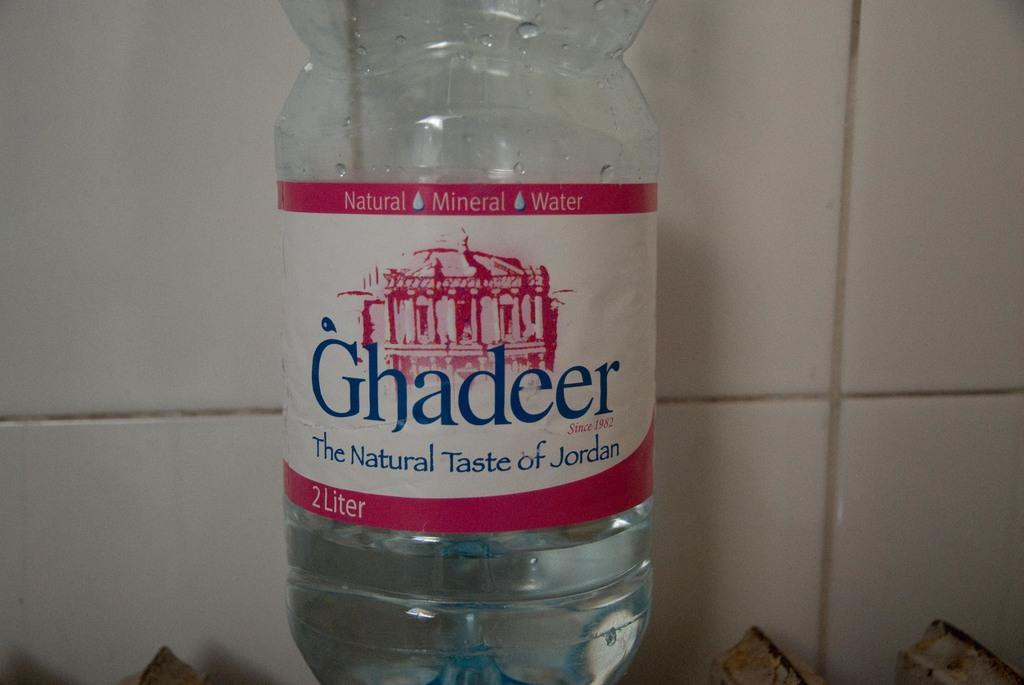<image>
Describe the image concisely. A waterbottle claims to have The Natural Taste of Jordan 